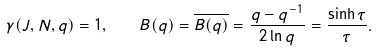<formula> <loc_0><loc_0><loc_500><loc_500>\gamma ( J , N , q ) = 1 , \quad B ( q ) = \overline { B ( q ) } = \frac { q - q ^ { - 1 } } { 2 \ln q } = \frac { \sinh \tau } { \tau } .</formula> 